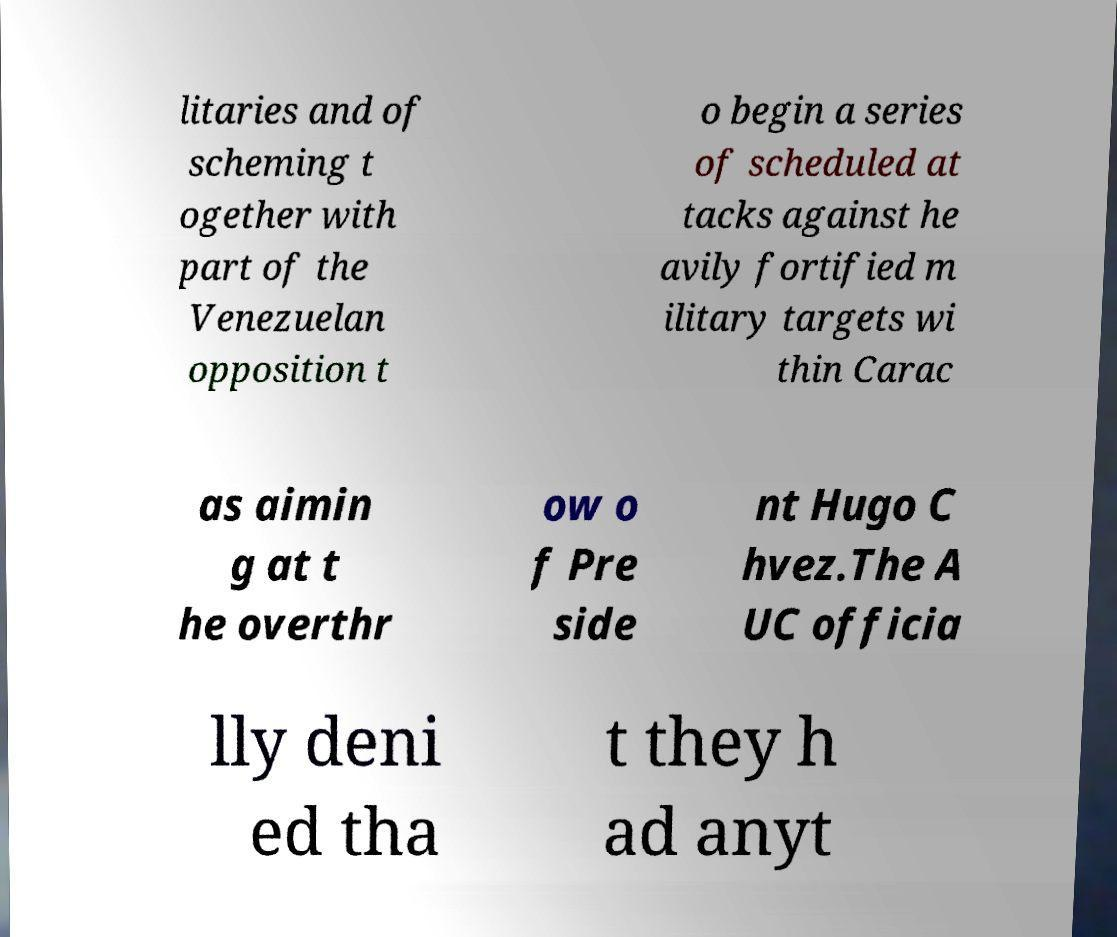Could you assist in decoding the text presented in this image and type it out clearly? litaries and of scheming t ogether with part of the Venezuelan opposition t o begin a series of scheduled at tacks against he avily fortified m ilitary targets wi thin Carac as aimin g at t he overthr ow o f Pre side nt Hugo C hvez.The A UC officia lly deni ed tha t they h ad anyt 